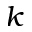Convert formula to latex. <formula><loc_0><loc_0><loc_500><loc_500>k</formula> 